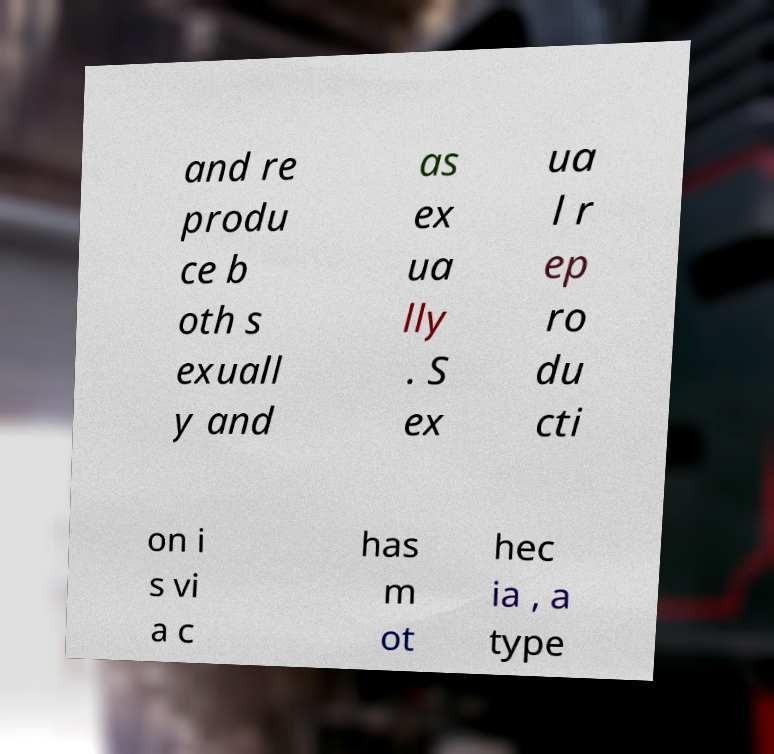There's text embedded in this image that I need extracted. Can you transcribe it verbatim? and re produ ce b oth s exuall y and as ex ua lly . S ex ua l r ep ro du cti on i s vi a c has m ot hec ia , a type 